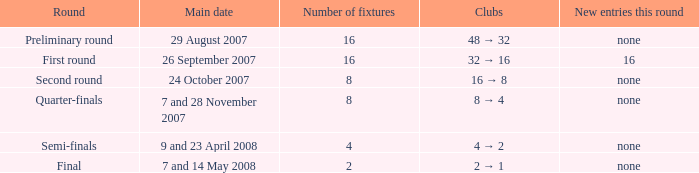What is the Clubs when there are 4 for the number of fixtures? 4 → 2. 